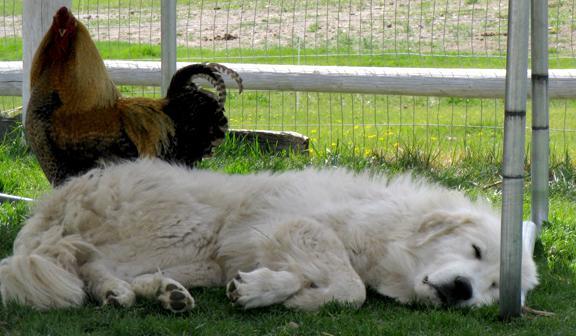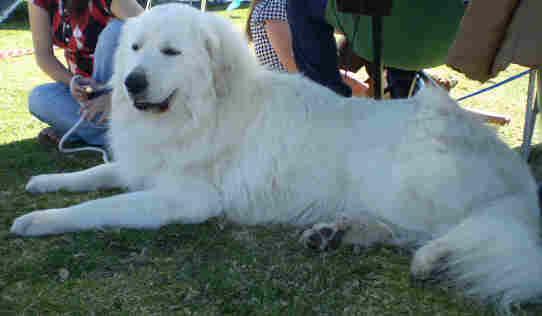The first image is the image on the left, the second image is the image on the right. Examine the images to the left and right. Is the description "In one of the images, a white dog is laying down behind at least three framed documents." accurate? Answer yes or no. No. The first image is the image on the left, the second image is the image on the right. Given the left and right images, does the statement "An image contains a large white dog laying down next to framed certificates." hold true? Answer yes or no. No. 